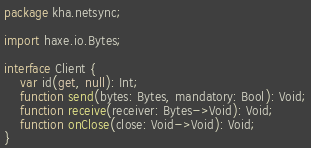Convert code to text. <code><loc_0><loc_0><loc_500><loc_500><_Haxe_>package kha.netsync;

import haxe.io.Bytes;

interface Client {
	var id(get, null): Int;
	function send(bytes: Bytes, mandatory: Bool): Void;
	function receive(receiver: Bytes->Void): Void;
	function onClose(close: Void->Void): Void;
}
</code> 